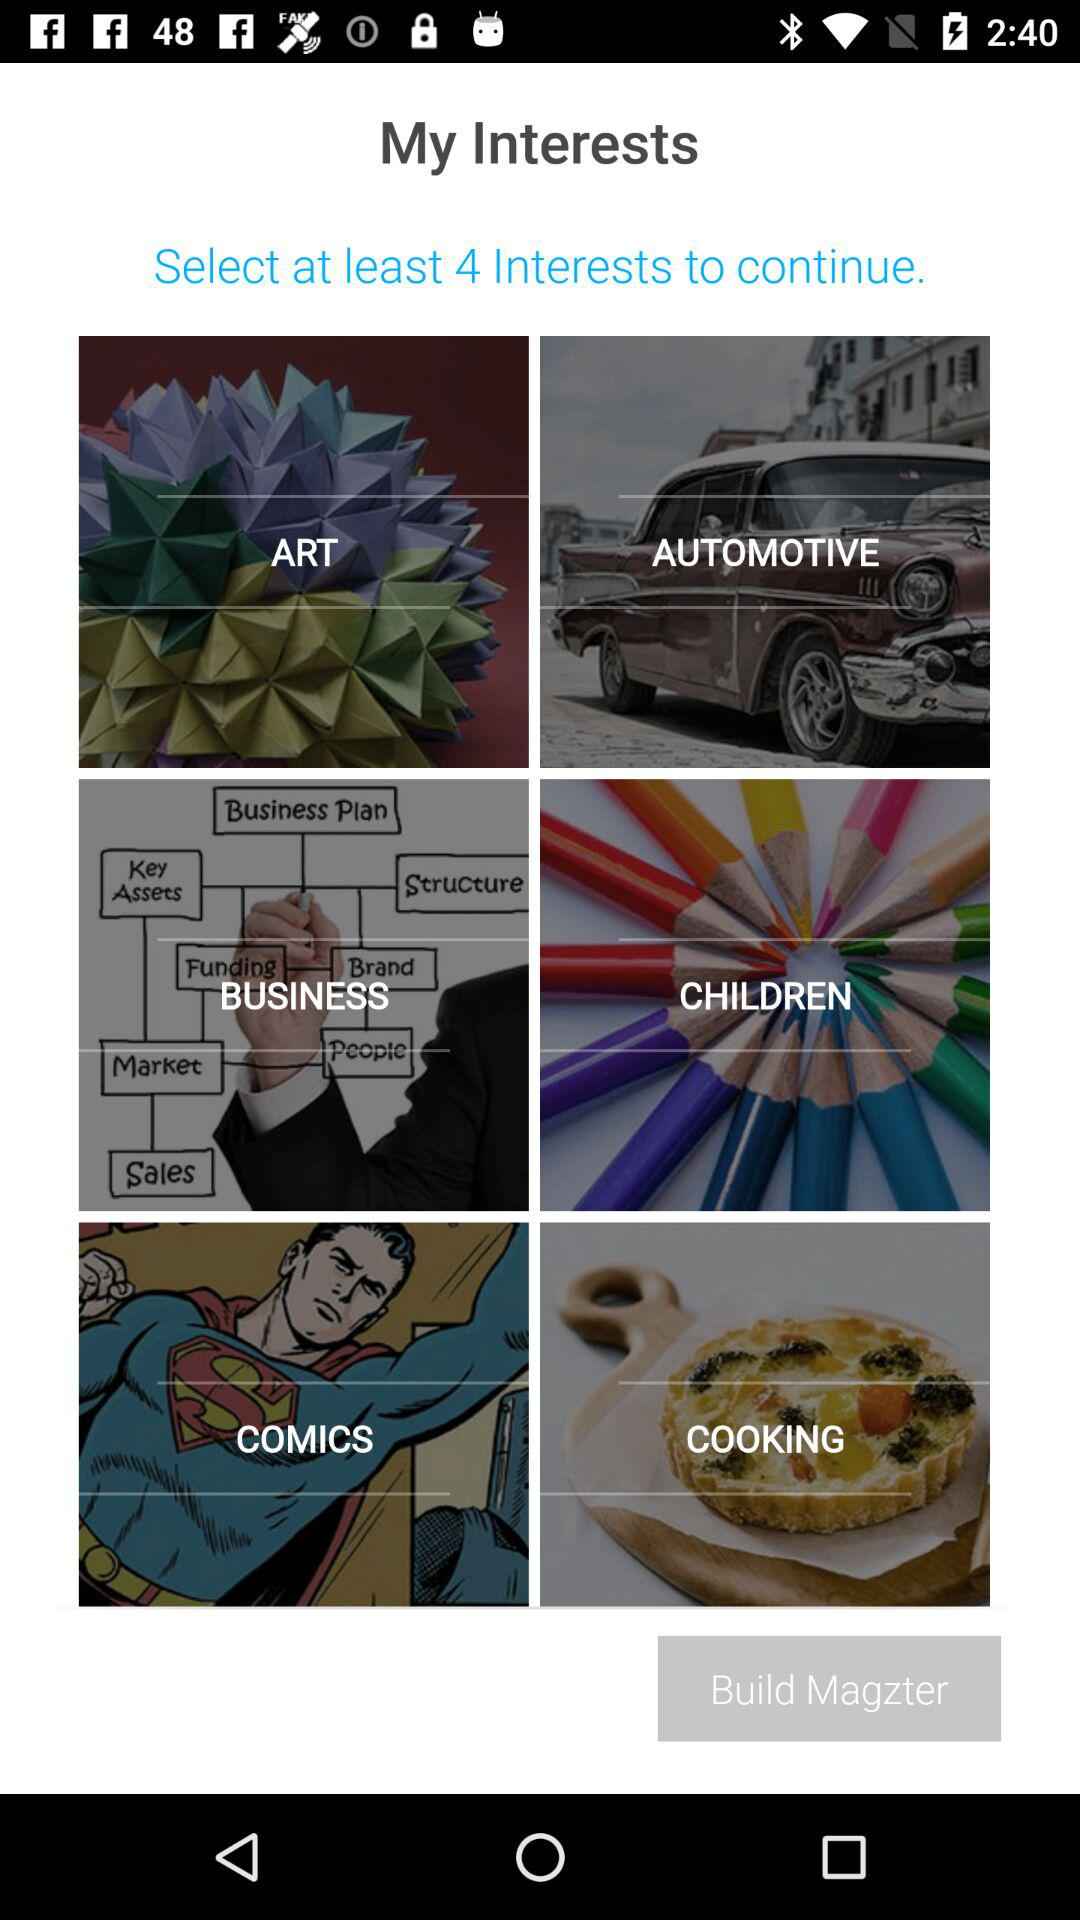How many interests are there to choose from?
Answer the question using a single word or phrase. 6 